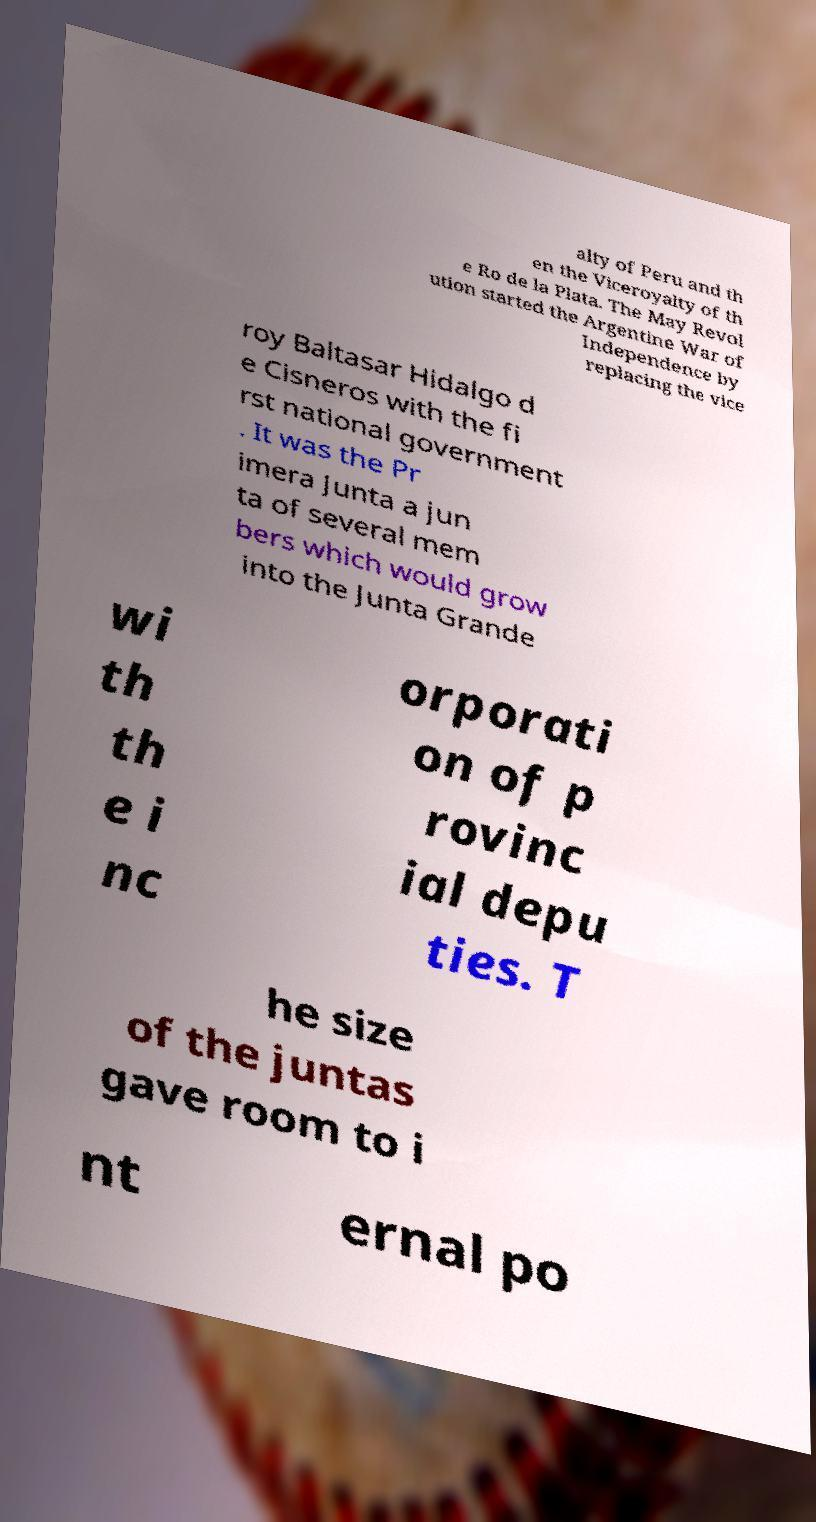Could you extract and type out the text from this image? alty of Peru and th en the Viceroyalty of th e Ro de la Plata. The May Revol ution started the Argentine War of Independence by replacing the vice roy Baltasar Hidalgo d e Cisneros with the fi rst national government . It was the Pr imera Junta a jun ta of several mem bers which would grow into the Junta Grande wi th th e i nc orporati on of p rovinc ial depu ties. T he size of the juntas gave room to i nt ernal po 